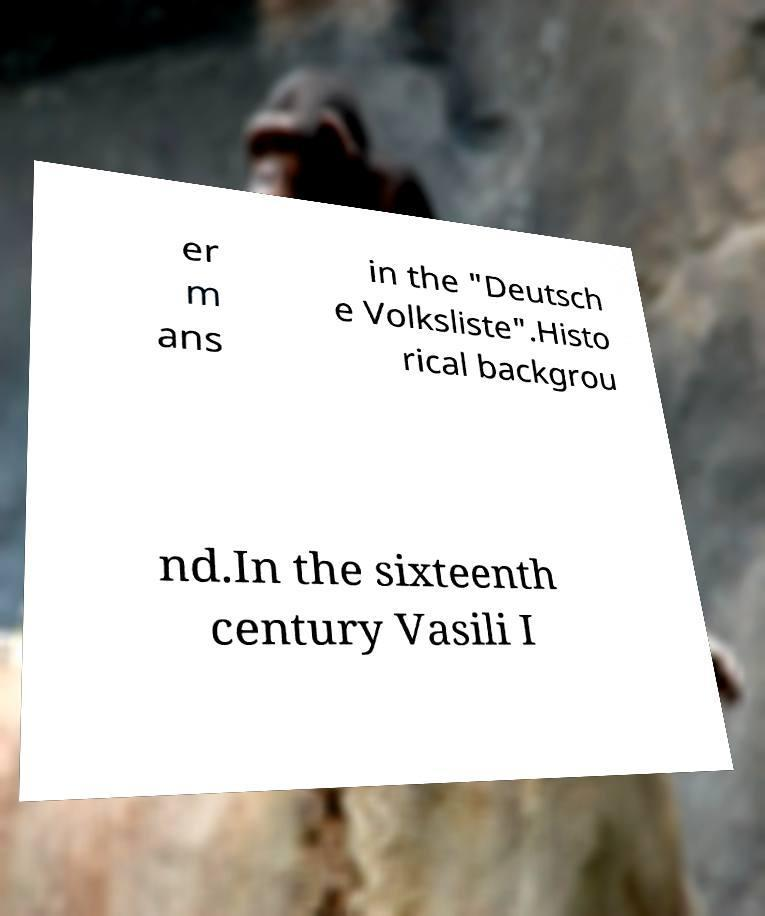What messages or text are displayed in this image? I need them in a readable, typed format. er m ans in the "Deutsch e Volksliste".Histo rical backgrou nd.In the sixteenth century Vasili I 